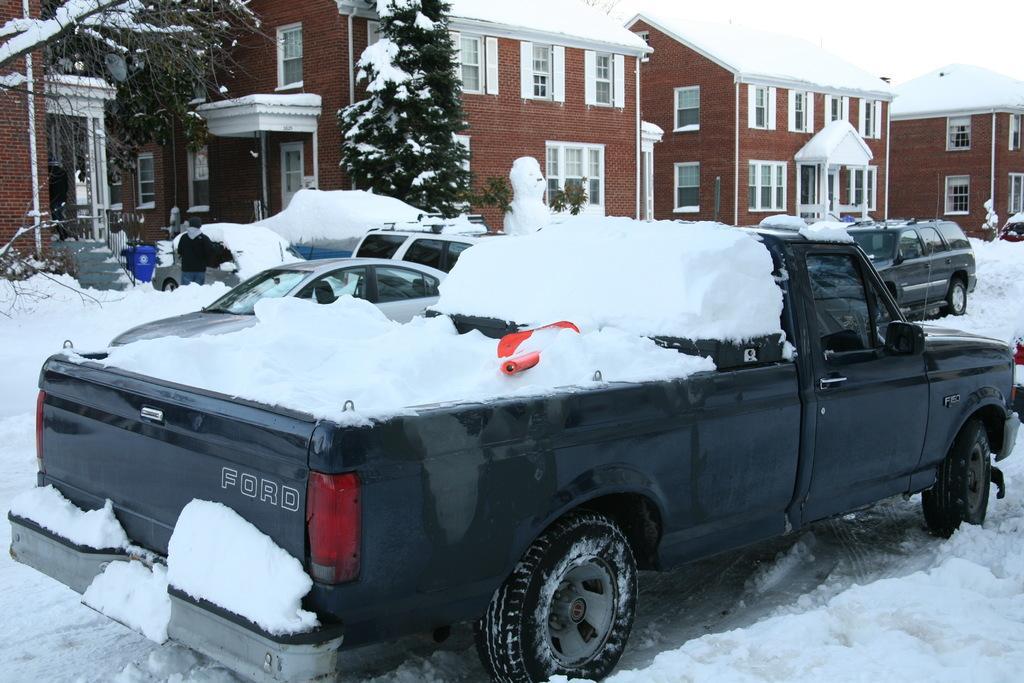Could you give a brief overview of what you see in this image? In the image we can see the buildings and windows of the buildings. We can even see there are trees, vehicles, snow and the sky. Here we can see a man standing, wearing clothes and here we can see the stairs. 